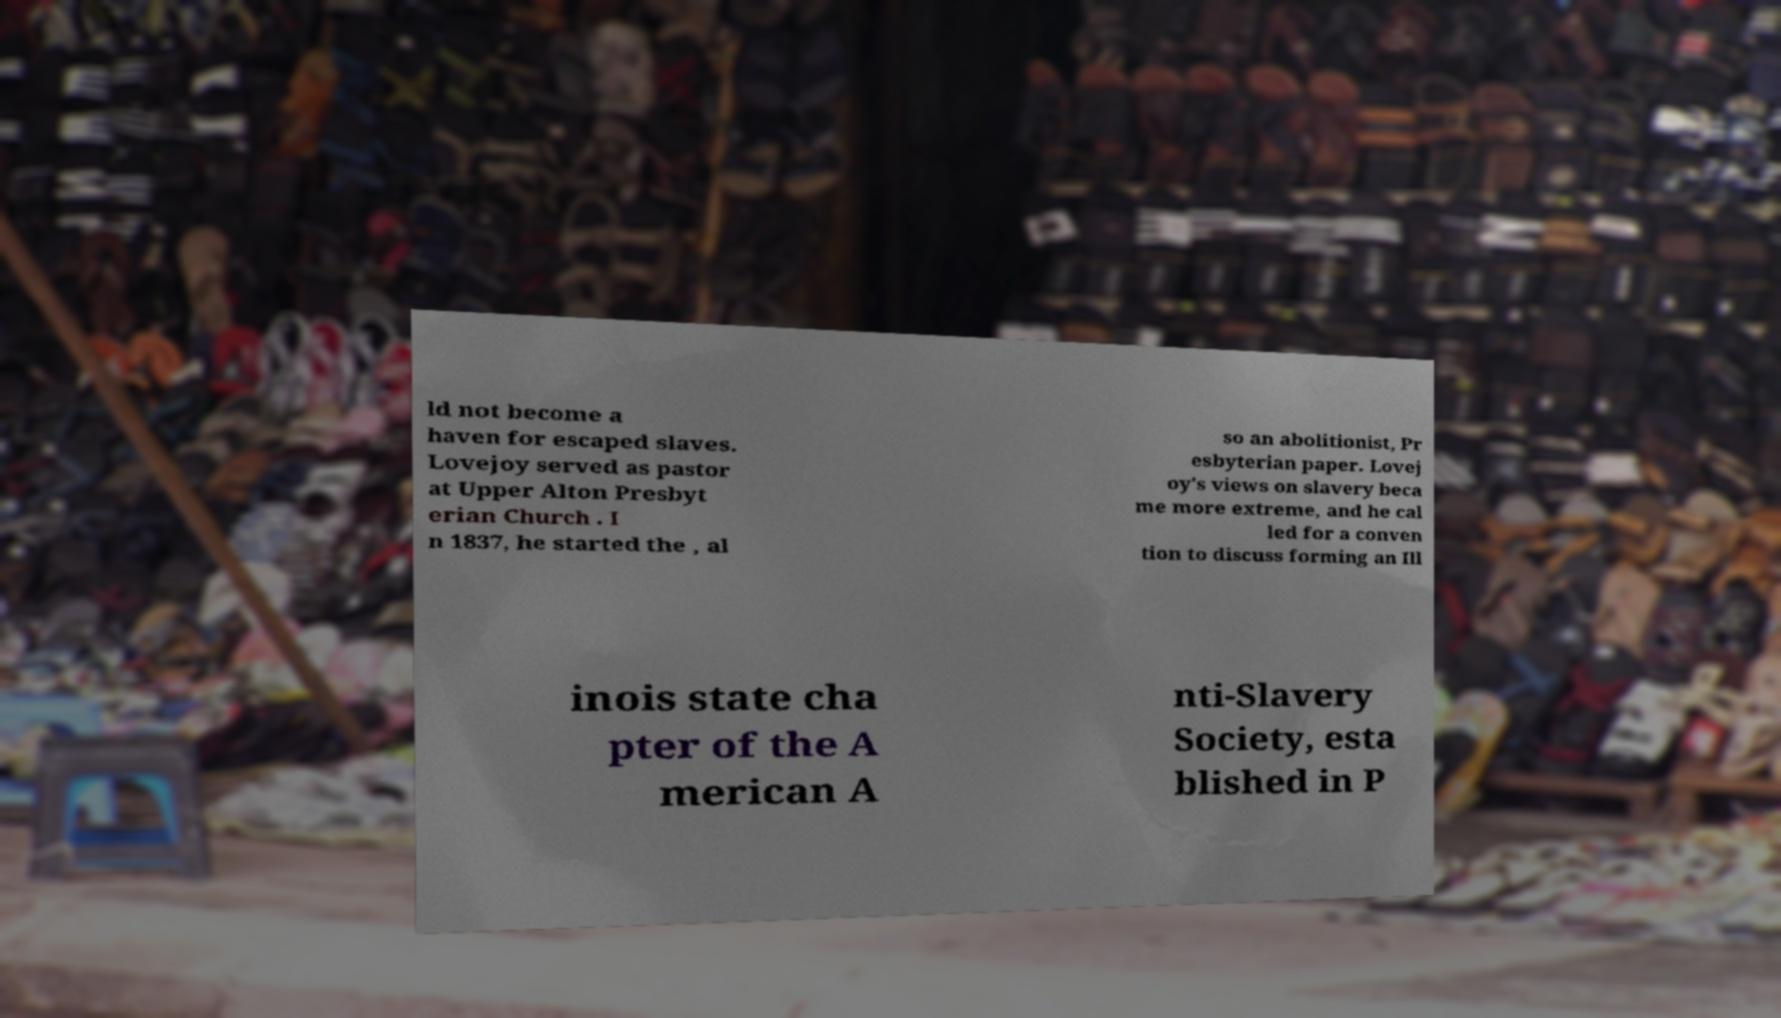For documentation purposes, I need the text within this image transcribed. Could you provide that? ld not become a haven for escaped slaves. Lovejoy served as pastor at Upper Alton Presbyt erian Church . I n 1837, he started the , al so an abolitionist, Pr esbyterian paper. Lovej oy's views on slavery beca me more extreme, and he cal led for a conven tion to discuss forming an Ill inois state cha pter of the A merican A nti-Slavery Society, esta blished in P 